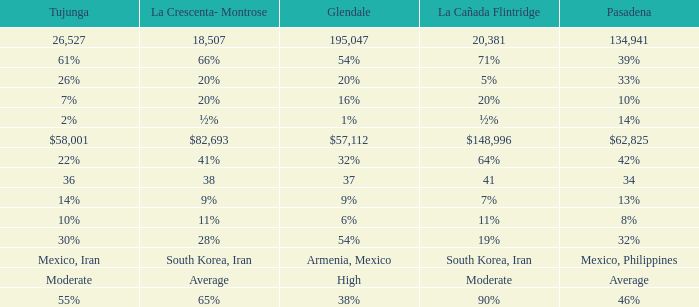When Tujunga is moderate, what is La Crescenta-Montrose? Average. 